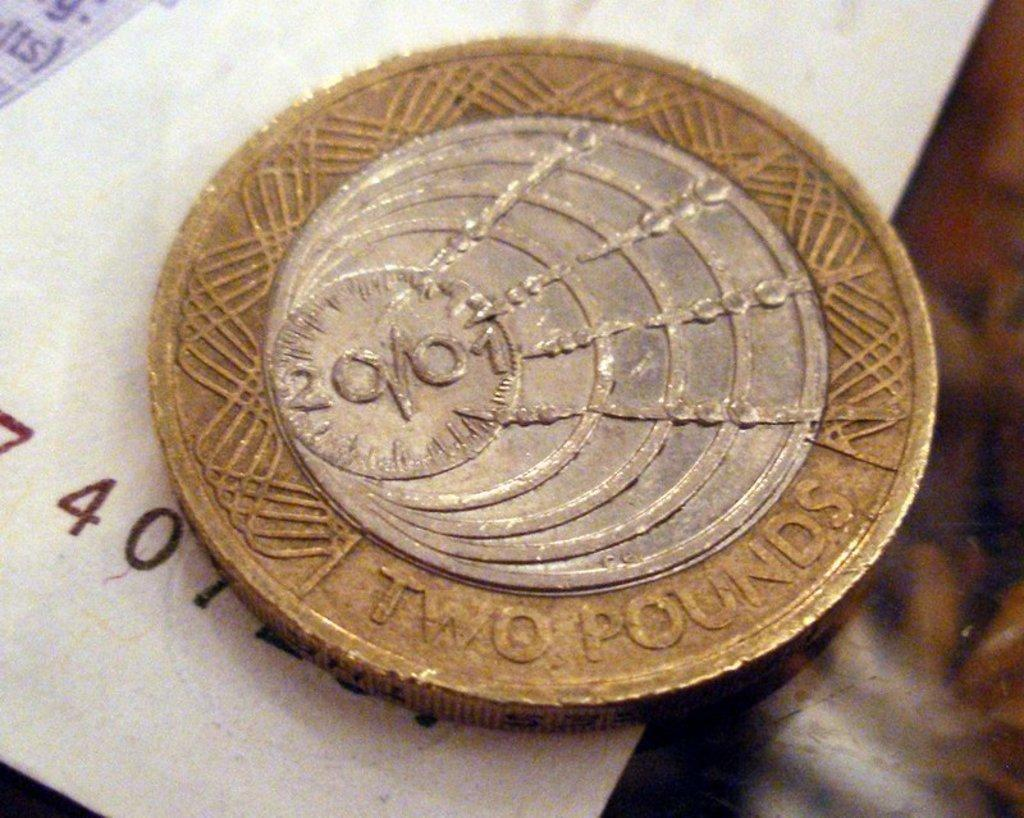<image>
Render a clear and concise summary of the photo. Gold and silver coin that says Two Pounds on it. 